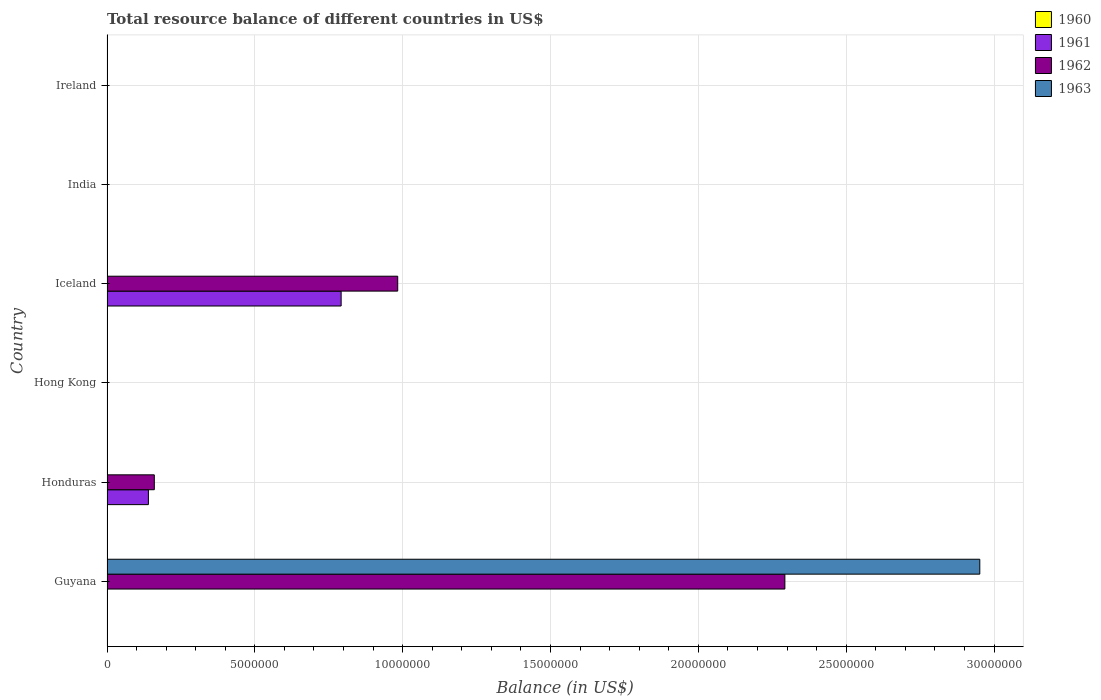How many different coloured bars are there?
Offer a very short reply. 3. How many bars are there on the 3rd tick from the top?
Provide a succinct answer. 2. How many bars are there on the 2nd tick from the bottom?
Provide a short and direct response. 2. What is the label of the 5th group of bars from the top?
Your answer should be compact. Honduras. What is the total resource balance in 1961 in India?
Your response must be concise. 0. Across all countries, what is the maximum total resource balance in 1961?
Keep it short and to the point. 7.92e+06. In which country was the total resource balance in 1962 maximum?
Make the answer very short. Guyana. What is the difference between the total resource balance in 1962 in Guyana and that in Honduras?
Provide a succinct answer. 2.13e+07. What is the difference between the total resource balance in 1963 in Ireland and the total resource balance in 1961 in Honduras?
Offer a terse response. -1.40e+06. What is the difference between the total resource balance in 1962 and total resource balance in 1961 in Honduras?
Your answer should be compact. 2.00e+05. In how many countries, is the total resource balance in 1962 greater than 2000000 US$?
Offer a terse response. 2. Is the difference between the total resource balance in 1962 in Honduras and Iceland greater than the difference between the total resource balance in 1961 in Honduras and Iceland?
Ensure brevity in your answer.  No. What is the difference between the highest and the second highest total resource balance in 1962?
Keep it short and to the point. 1.31e+07. What is the difference between the highest and the lowest total resource balance in 1963?
Keep it short and to the point. 2.95e+07. In how many countries, is the total resource balance in 1961 greater than the average total resource balance in 1961 taken over all countries?
Keep it short and to the point. 1. Are all the bars in the graph horizontal?
Make the answer very short. Yes. Does the graph contain any zero values?
Make the answer very short. Yes. Does the graph contain grids?
Give a very brief answer. Yes. Where does the legend appear in the graph?
Your response must be concise. Top right. What is the title of the graph?
Provide a short and direct response. Total resource balance of different countries in US$. Does "1965" appear as one of the legend labels in the graph?
Keep it short and to the point. No. What is the label or title of the X-axis?
Provide a short and direct response. Balance (in US$). What is the label or title of the Y-axis?
Ensure brevity in your answer.  Country. What is the Balance (in US$) of 1961 in Guyana?
Keep it short and to the point. 0. What is the Balance (in US$) in 1962 in Guyana?
Give a very brief answer. 2.29e+07. What is the Balance (in US$) of 1963 in Guyana?
Your response must be concise. 2.95e+07. What is the Balance (in US$) of 1960 in Honduras?
Make the answer very short. 0. What is the Balance (in US$) of 1961 in Honduras?
Make the answer very short. 1.40e+06. What is the Balance (in US$) in 1962 in Honduras?
Ensure brevity in your answer.  1.60e+06. What is the Balance (in US$) of 1960 in Hong Kong?
Give a very brief answer. 0. What is the Balance (in US$) in 1962 in Hong Kong?
Provide a short and direct response. 0. What is the Balance (in US$) in 1960 in Iceland?
Offer a terse response. 0. What is the Balance (in US$) in 1961 in Iceland?
Provide a succinct answer. 7.92e+06. What is the Balance (in US$) in 1962 in Iceland?
Provide a succinct answer. 9.83e+06. What is the Balance (in US$) in 1963 in Iceland?
Offer a very short reply. 0. What is the Balance (in US$) of 1960 in India?
Provide a succinct answer. 0. What is the Balance (in US$) in 1961 in India?
Provide a short and direct response. 0. What is the Balance (in US$) of 1962 in India?
Offer a terse response. 0. What is the Balance (in US$) in 1960 in Ireland?
Your response must be concise. 0. What is the Balance (in US$) of 1961 in Ireland?
Your answer should be compact. 0. What is the Balance (in US$) in 1963 in Ireland?
Your answer should be very brief. 0. Across all countries, what is the maximum Balance (in US$) in 1961?
Keep it short and to the point. 7.92e+06. Across all countries, what is the maximum Balance (in US$) in 1962?
Offer a terse response. 2.29e+07. Across all countries, what is the maximum Balance (in US$) in 1963?
Your answer should be compact. 2.95e+07. Across all countries, what is the minimum Balance (in US$) in 1961?
Your response must be concise. 0. Across all countries, what is the minimum Balance (in US$) in 1962?
Your response must be concise. 0. What is the total Balance (in US$) of 1960 in the graph?
Your answer should be very brief. 0. What is the total Balance (in US$) of 1961 in the graph?
Ensure brevity in your answer.  9.32e+06. What is the total Balance (in US$) of 1962 in the graph?
Make the answer very short. 3.44e+07. What is the total Balance (in US$) in 1963 in the graph?
Provide a succinct answer. 2.95e+07. What is the difference between the Balance (in US$) in 1962 in Guyana and that in Honduras?
Provide a succinct answer. 2.13e+07. What is the difference between the Balance (in US$) of 1962 in Guyana and that in Iceland?
Provide a short and direct response. 1.31e+07. What is the difference between the Balance (in US$) of 1961 in Honduras and that in Iceland?
Make the answer very short. -6.52e+06. What is the difference between the Balance (in US$) in 1962 in Honduras and that in Iceland?
Ensure brevity in your answer.  -8.23e+06. What is the difference between the Balance (in US$) of 1961 in Honduras and the Balance (in US$) of 1962 in Iceland?
Your answer should be very brief. -8.43e+06. What is the average Balance (in US$) of 1960 per country?
Offer a very short reply. 0. What is the average Balance (in US$) of 1961 per country?
Give a very brief answer. 1.55e+06. What is the average Balance (in US$) of 1962 per country?
Keep it short and to the point. 5.73e+06. What is the average Balance (in US$) in 1963 per country?
Ensure brevity in your answer.  4.92e+06. What is the difference between the Balance (in US$) of 1962 and Balance (in US$) of 1963 in Guyana?
Ensure brevity in your answer.  -6.59e+06. What is the difference between the Balance (in US$) in 1961 and Balance (in US$) in 1962 in Iceland?
Your answer should be very brief. -1.91e+06. What is the ratio of the Balance (in US$) in 1962 in Guyana to that in Honduras?
Provide a short and direct response. 14.33. What is the ratio of the Balance (in US$) in 1962 in Guyana to that in Iceland?
Provide a succinct answer. 2.33. What is the ratio of the Balance (in US$) in 1961 in Honduras to that in Iceland?
Give a very brief answer. 0.18. What is the ratio of the Balance (in US$) in 1962 in Honduras to that in Iceland?
Your answer should be compact. 0.16. What is the difference between the highest and the second highest Balance (in US$) of 1962?
Ensure brevity in your answer.  1.31e+07. What is the difference between the highest and the lowest Balance (in US$) in 1961?
Offer a very short reply. 7.92e+06. What is the difference between the highest and the lowest Balance (in US$) in 1962?
Offer a terse response. 2.29e+07. What is the difference between the highest and the lowest Balance (in US$) of 1963?
Ensure brevity in your answer.  2.95e+07. 